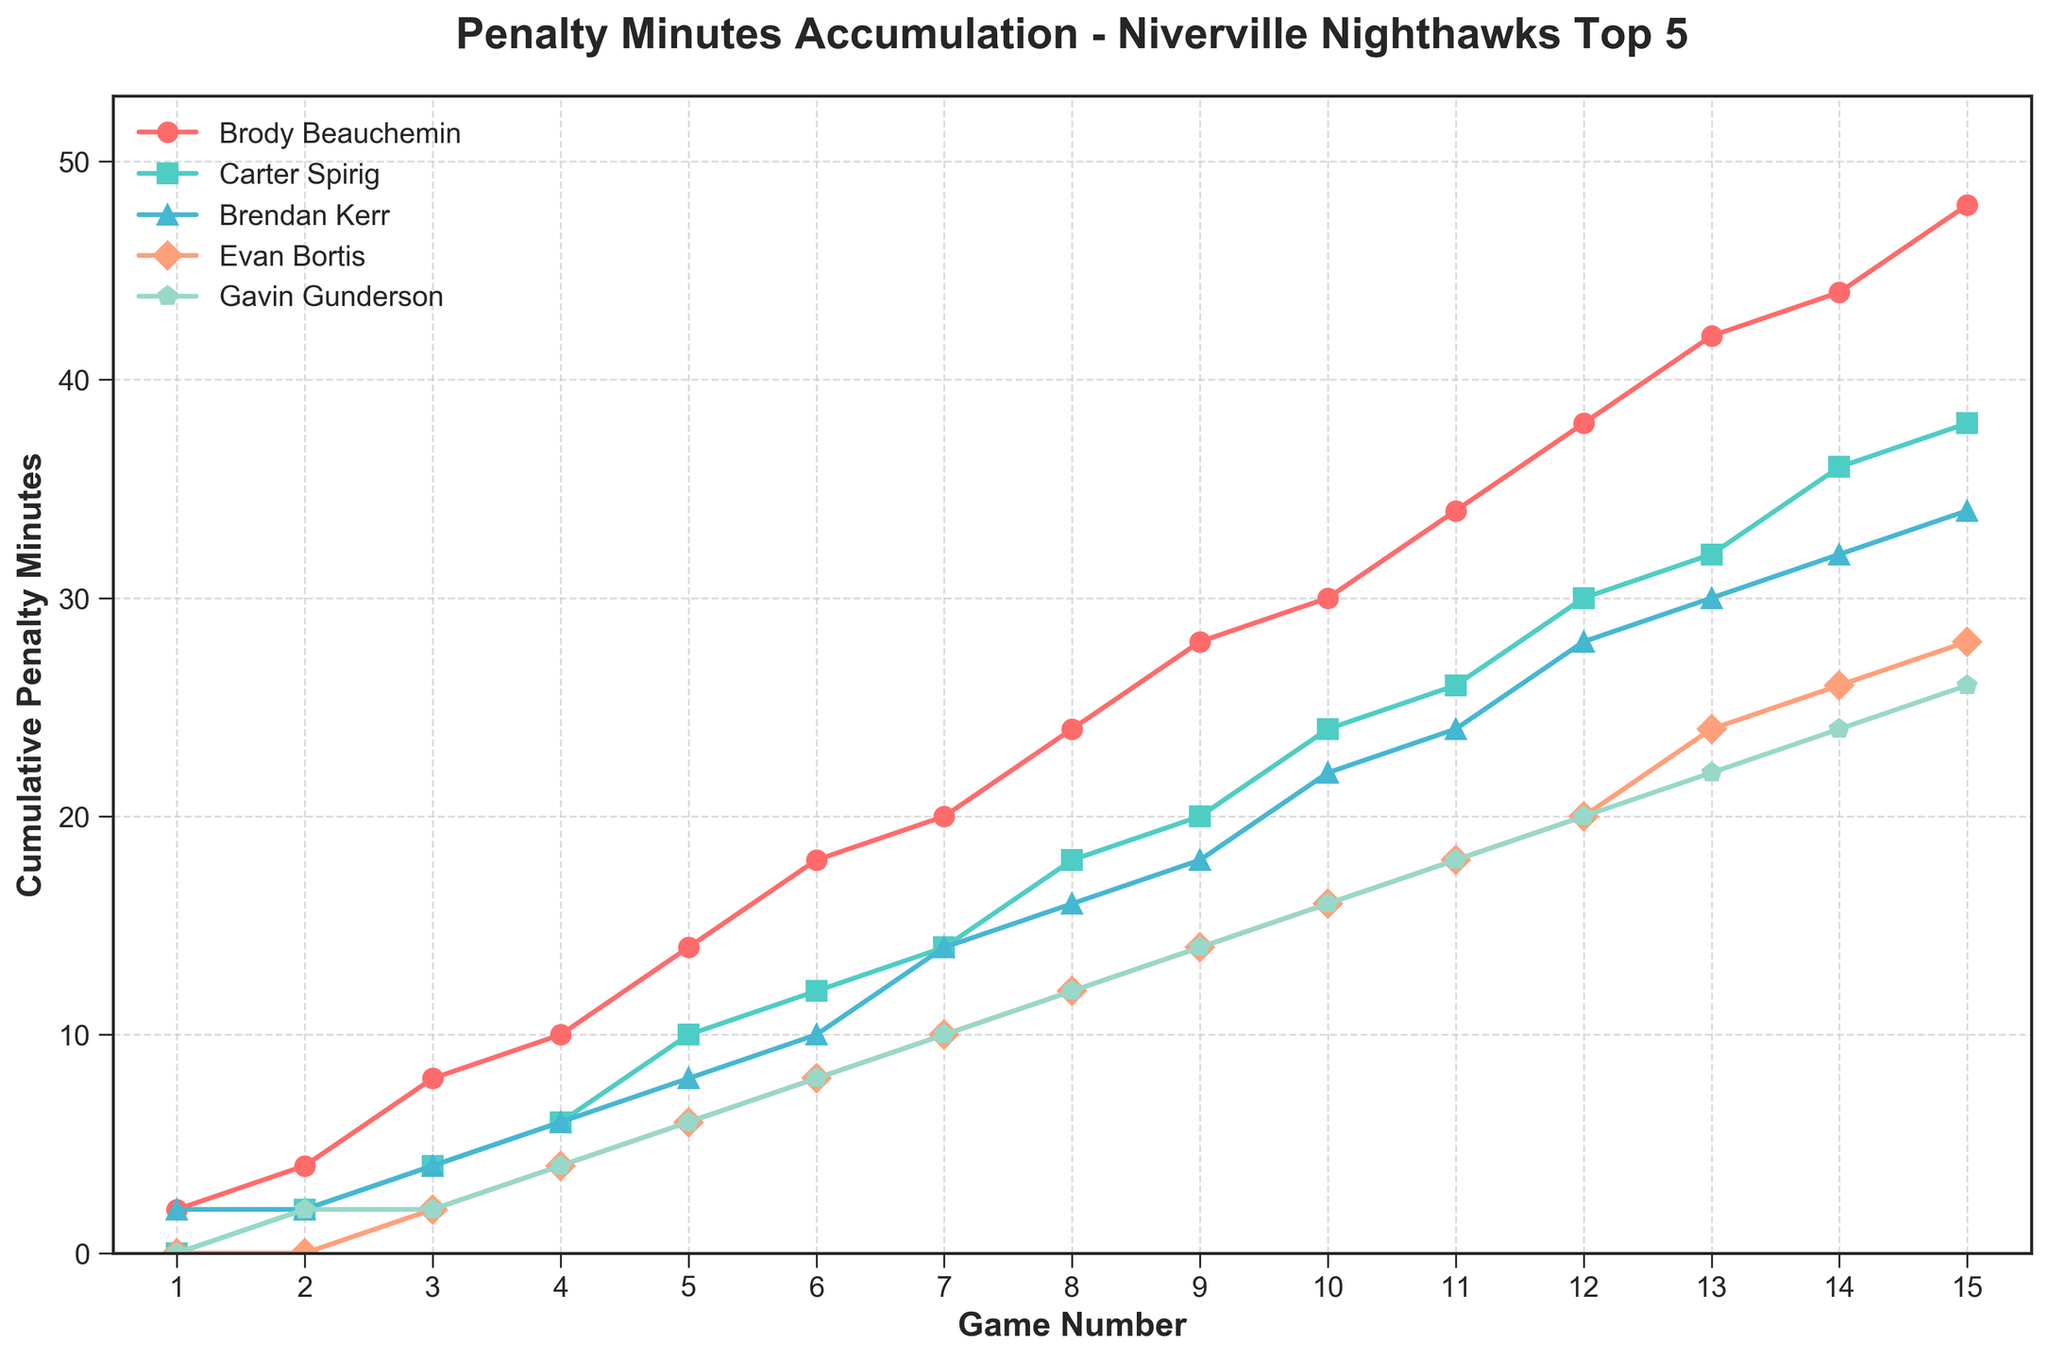Which player accumulated the most penalty minutes by Game 10? By Game 10, Brody Beauchemin had accumulated 30 penalty minutes, which is higher than any other player on the team at that point.
Answer: Brody Beauchemin Between Games 5 and 10, which player's cumulative penalty minutes increased the most? Brody Beauchemin's penalty minutes increased from 14 to 30, a difference of 16 minutes. This increase is more significant than for any other player during Games 5 to 10.
Answer: Brody Beauchemin Who had the least penalty minutes overall by the end of Game 15? By the end of Game 15, both Evan Bortis and Gavin Gunderson accumulated 28 penalty minutes, which is lower than any of the other three players.
Answer: Evan Bortis and Gavin Gunderson Compare the cumulative penalty minutes of Carter Spirig and Brendan Kerr at Game 8. Who had more? At Game 8, Carter Spirig had 18 penalty minutes, while Brendan Kerr had 16 penalty minutes, so Carter Spirig had more.
Answer: Carter Spirig What is the total penalty minutes accumulated by all five players by Game 15? Summing the penalty minutes of Brody Beauchemin (48), Carter Spirig (38), Brendan Kerr (34), Evan Bortis (28), and Gavin Gunderson (26) gives the total penalty minutes: 48 + 38 + 34 + 28 + 26 = 174
Answer: 174 Which player had the most consistent increase in their penalty minutes accumulation? Gavin Gunderson's penalty minutes increased in a mostly linear and consistent manner from 2 minutes in Game 2 to 26 minutes in Game 15. The increments were steady across the games compared to the other players.
Answer: Gavin Gunderson Looking at the rate of increase, which player had the highest penalty minutes increase between Game 4 and Game 8? Between Game 4 and 8, Brody Beauchemin's penalty minutes increased from 10 to 24, an increase of 14 minutes, which is the highest among the players during this interval.
Answer: Brody Beauchemin At Game 12, which player had the lowest cumulative penalty minutes? By Game 12, Evan Bortis had accumulated 20 penalty minutes, which is the least among all the players at that point.
Answer: Evan Bortis 